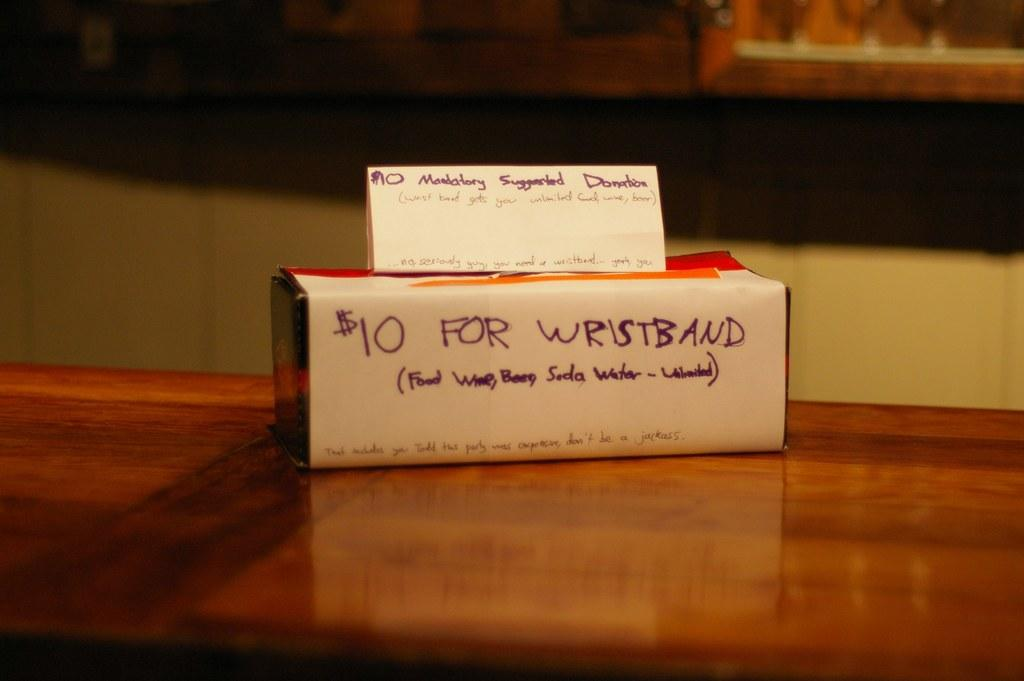<image>
Share a concise interpretation of the image provided. The white box says it is $10 for a wristband. 